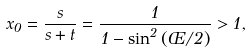<formula> <loc_0><loc_0><loc_500><loc_500>x _ { 0 } = \frac { s } { s + t } = \frac { 1 } { 1 - \sin ^ { 2 } \left ( \phi / 2 \right ) } > 1 ,</formula> 